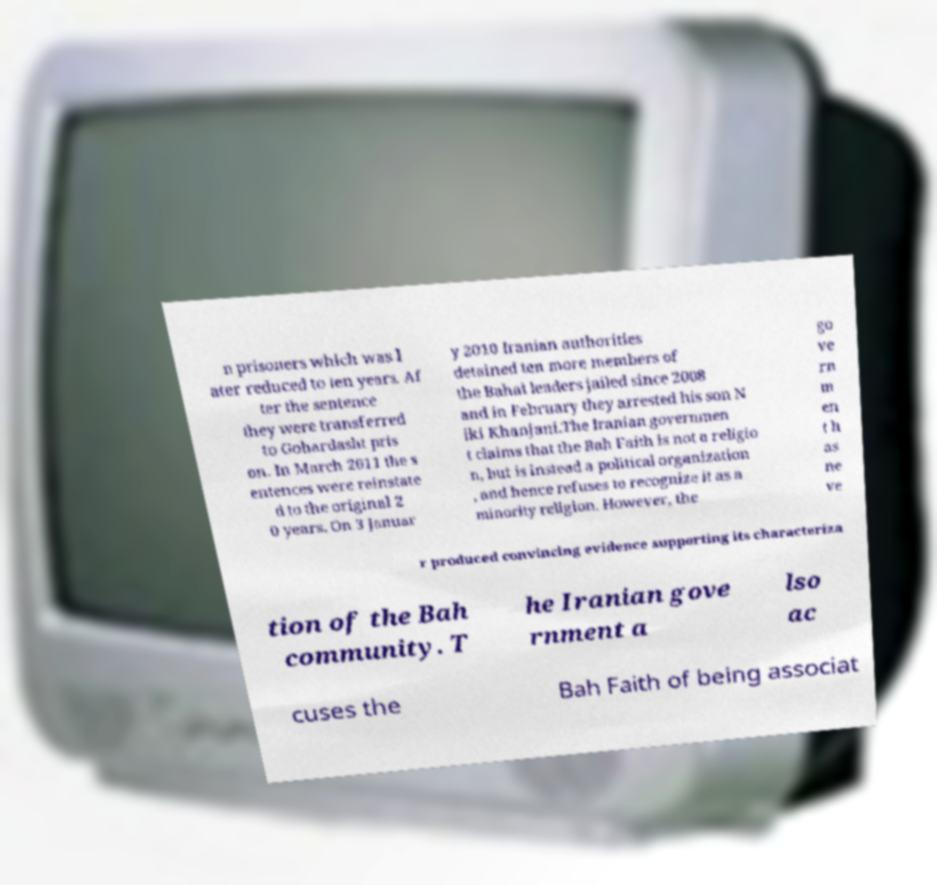Please identify and transcribe the text found in this image. n prisoners which was l ater reduced to ten years. Af ter the sentence they were transferred to Gohardasht pris on. In March 2011 the s entences were reinstate d to the original 2 0 years. On 3 Januar y 2010 Iranian authorities detained ten more members of the Bahai leaders jailed since 2008 and in February they arrested his son N iki Khanjani.The Iranian governmen t claims that the Bah Faith is not a religio n, but is instead a political organization , and hence refuses to recognize it as a minority religion. However, the go ve rn m en t h as ne ve r produced convincing evidence supporting its characteriza tion of the Bah community. T he Iranian gove rnment a lso ac cuses the Bah Faith of being associat 